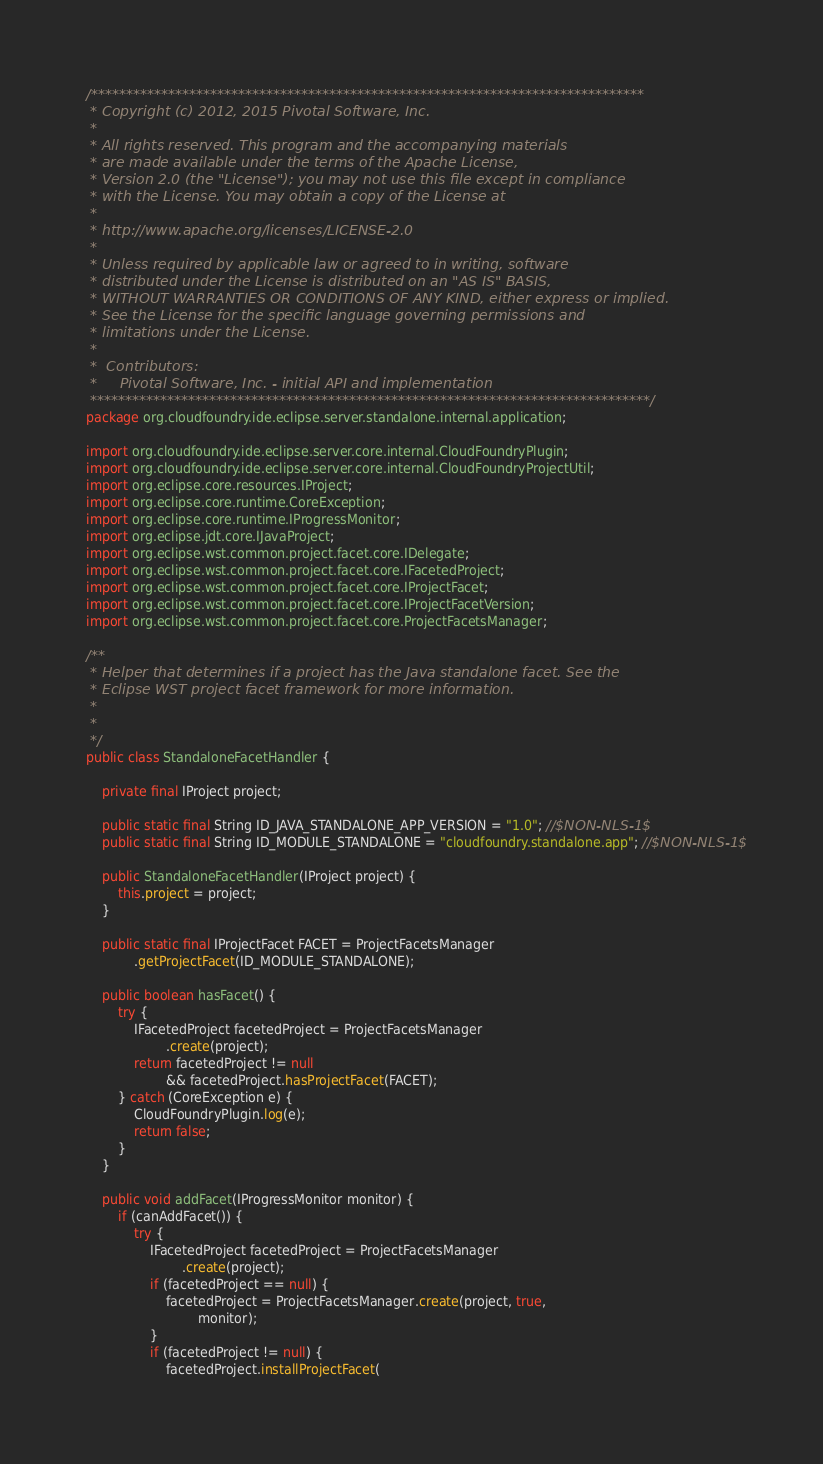Convert code to text. <code><loc_0><loc_0><loc_500><loc_500><_Java_>/*******************************************************************************
 * Copyright (c) 2012, 2015 Pivotal Software, Inc. 
 * 
 * All rights reserved. This program and the accompanying materials
 * are made available under the terms of the Apache License, 
 * Version 2.0 (the "License"); you may not use this file except in compliance 
 * with the License. You may obtain a copy of the License at
 *
 * http://www.apache.org/licenses/LICENSE-2.0
 *
 * Unless required by applicable law or agreed to in writing, software
 * distributed under the License is distributed on an "AS IS" BASIS,
 * WITHOUT WARRANTIES OR CONDITIONS OF ANY KIND, either express or implied.
 * See the License for the specific language governing permissions and
 * limitations under the License.
 *  
 *  Contributors:
 *     Pivotal Software, Inc. - initial API and implementation
 ********************************************************************************/
package org.cloudfoundry.ide.eclipse.server.standalone.internal.application;

import org.cloudfoundry.ide.eclipse.server.core.internal.CloudFoundryPlugin;
import org.cloudfoundry.ide.eclipse.server.core.internal.CloudFoundryProjectUtil;
import org.eclipse.core.resources.IProject;
import org.eclipse.core.runtime.CoreException;
import org.eclipse.core.runtime.IProgressMonitor;
import org.eclipse.jdt.core.IJavaProject;
import org.eclipse.wst.common.project.facet.core.IDelegate;
import org.eclipse.wst.common.project.facet.core.IFacetedProject;
import org.eclipse.wst.common.project.facet.core.IProjectFacet;
import org.eclipse.wst.common.project.facet.core.IProjectFacetVersion;
import org.eclipse.wst.common.project.facet.core.ProjectFacetsManager;

/**
 * Helper that determines if a project has the Java standalone facet. See the
 * Eclipse WST project facet framework for more information.
 * 
 * 
 */
public class StandaloneFacetHandler {

	private final IProject project;

	public static final String ID_JAVA_STANDALONE_APP_VERSION = "1.0"; //$NON-NLS-1$
	public static final String ID_MODULE_STANDALONE = "cloudfoundry.standalone.app"; //$NON-NLS-1$

	public StandaloneFacetHandler(IProject project) {
		this.project = project;
	}

	public static final IProjectFacet FACET = ProjectFacetsManager
			.getProjectFacet(ID_MODULE_STANDALONE);

	public boolean hasFacet() {
		try {
			IFacetedProject facetedProject = ProjectFacetsManager
					.create(project);
			return facetedProject != null
					&& facetedProject.hasProjectFacet(FACET);
		} catch (CoreException e) {
			CloudFoundryPlugin.log(e);
			return false;
		}
	}

	public void addFacet(IProgressMonitor monitor) {
		if (canAddFacet()) {
			try {
				IFacetedProject facetedProject = ProjectFacetsManager
						.create(project);
				if (facetedProject == null) {
					facetedProject = ProjectFacetsManager.create(project, true,
							monitor);
				}
				if (facetedProject != null) {
					facetedProject.installProjectFacet(</code> 